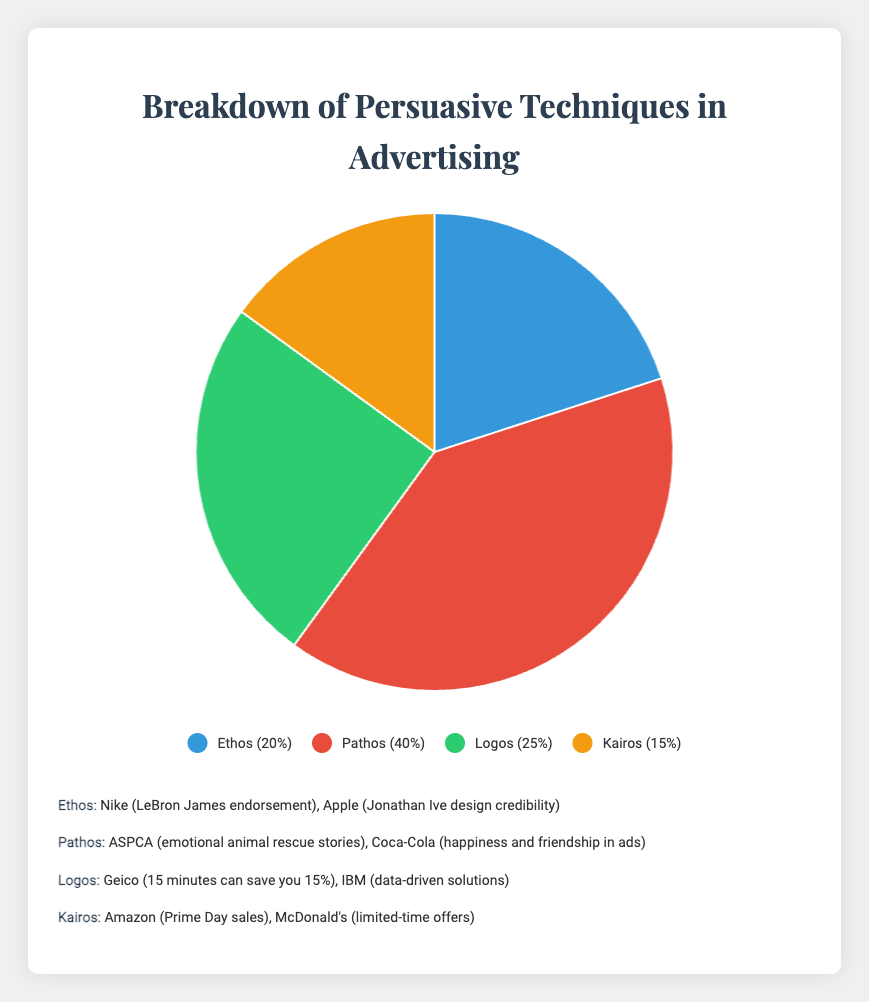What percentage of the advertisements use Pathos as a persuasive technique? To find the percentage, look at the segment labeled "Pathos" in the pie chart.
Answer: 40% Which technique accounts for the smallest percentage of the persuasive techniques used in advertisements? Compare the percentages of all the techniques and identify the smallest one, which is Kairos with 15%.
Answer: Kairos How much greater is the percentage of Pathos than Ethos? Subtract the percentage of Ethos (20%) from the percentage of Pathos (40%) to find the difference. 40% - 20% = 20%.
Answer: 20% What is the combined percentage of Ethos and Logos? Add the percentage of Ethos (20%) and Logos (25%). 20% + 25% = 45%.
Answer: 45% How does the percentage of Kairos compare to that of Logos? Compare the two percentages: Kairos (15%) and Logos (25%). Since 15% is less than 25%, Kairos is less than Logos.
Answer: Kairos is less than Logos Which persuasive technique is depicted using the green color in the pie chart? Look at the pie chart and identify the segment colored green; in this case, it's Logos.
Answer: Logos What is the percentage difference between the highest and the lowest persuasive techniques used? Identify the highest (Pathos at 40%) and the lowest (Kairos at 15%), then subtract the lowest from the highest: 40% - 15% = 25%.
Answer: 25% If you were to divide the techniques into two groups, where one group includes Pathos and the other includes the rest, what would be the percentage representation of each group? Pathos is 40%. The rest (Ethos, Logos, Kairos) sum up to 20% + 25% + 15% = 60%. Hence, Pathos is 40% and the rest is 60%.
Answer: Pathos: 40%, Others: 60% Which techniques have a combined percentage greater than 50%? Add up the percentages of different combinations to see which one exceeds 50%. Pathos (40%) + Logos (25%) = 65% (greater than 50%).
Answer: Pathos and Logos What is the average percentage of all the techniques? Sum up all the percentages (20% + 40% + 25% + 15% = 100%) and divide by the number of techniques (4). 100% / 4 = 25%.
Answer: 25% 